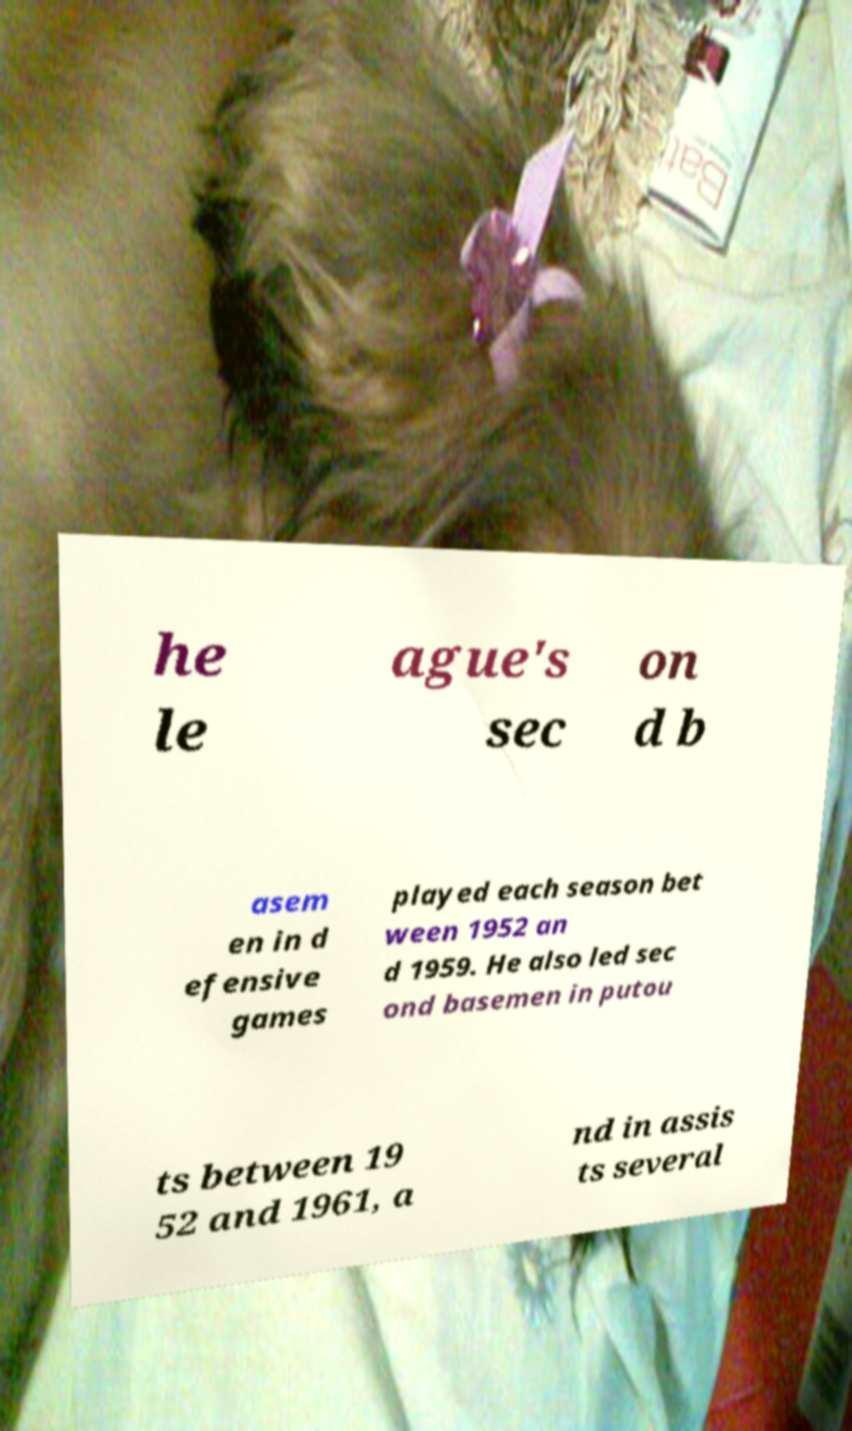What messages or text are displayed in this image? I need them in a readable, typed format. he le ague's sec on d b asem en in d efensive games played each season bet ween 1952 an d 1959. He also led sec ond basemen in putou ts between 19 52 and 1961, a nd in assis ts several 